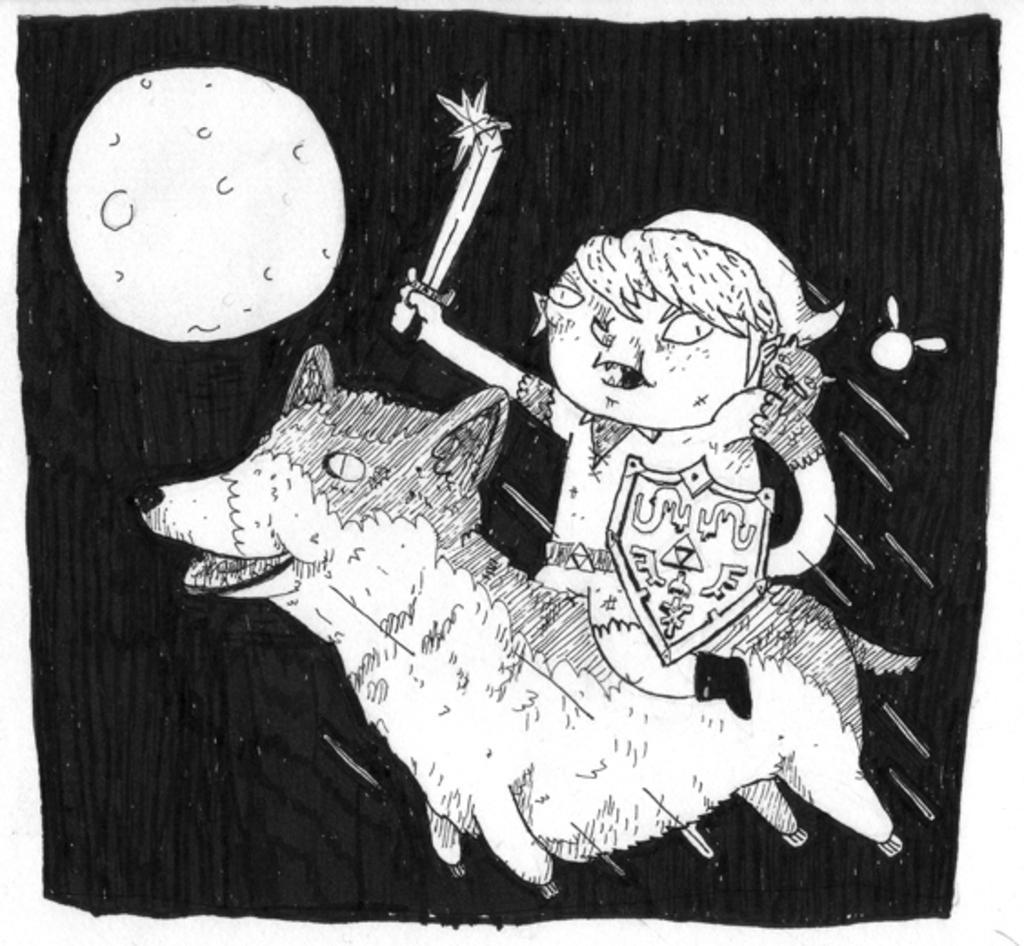Describe this image in one or two sentences. In this picture I can see there is a girl holding a sword and riding a horse and in the backdrop there is a moon and the backdrop is dark. This is a drawing. 